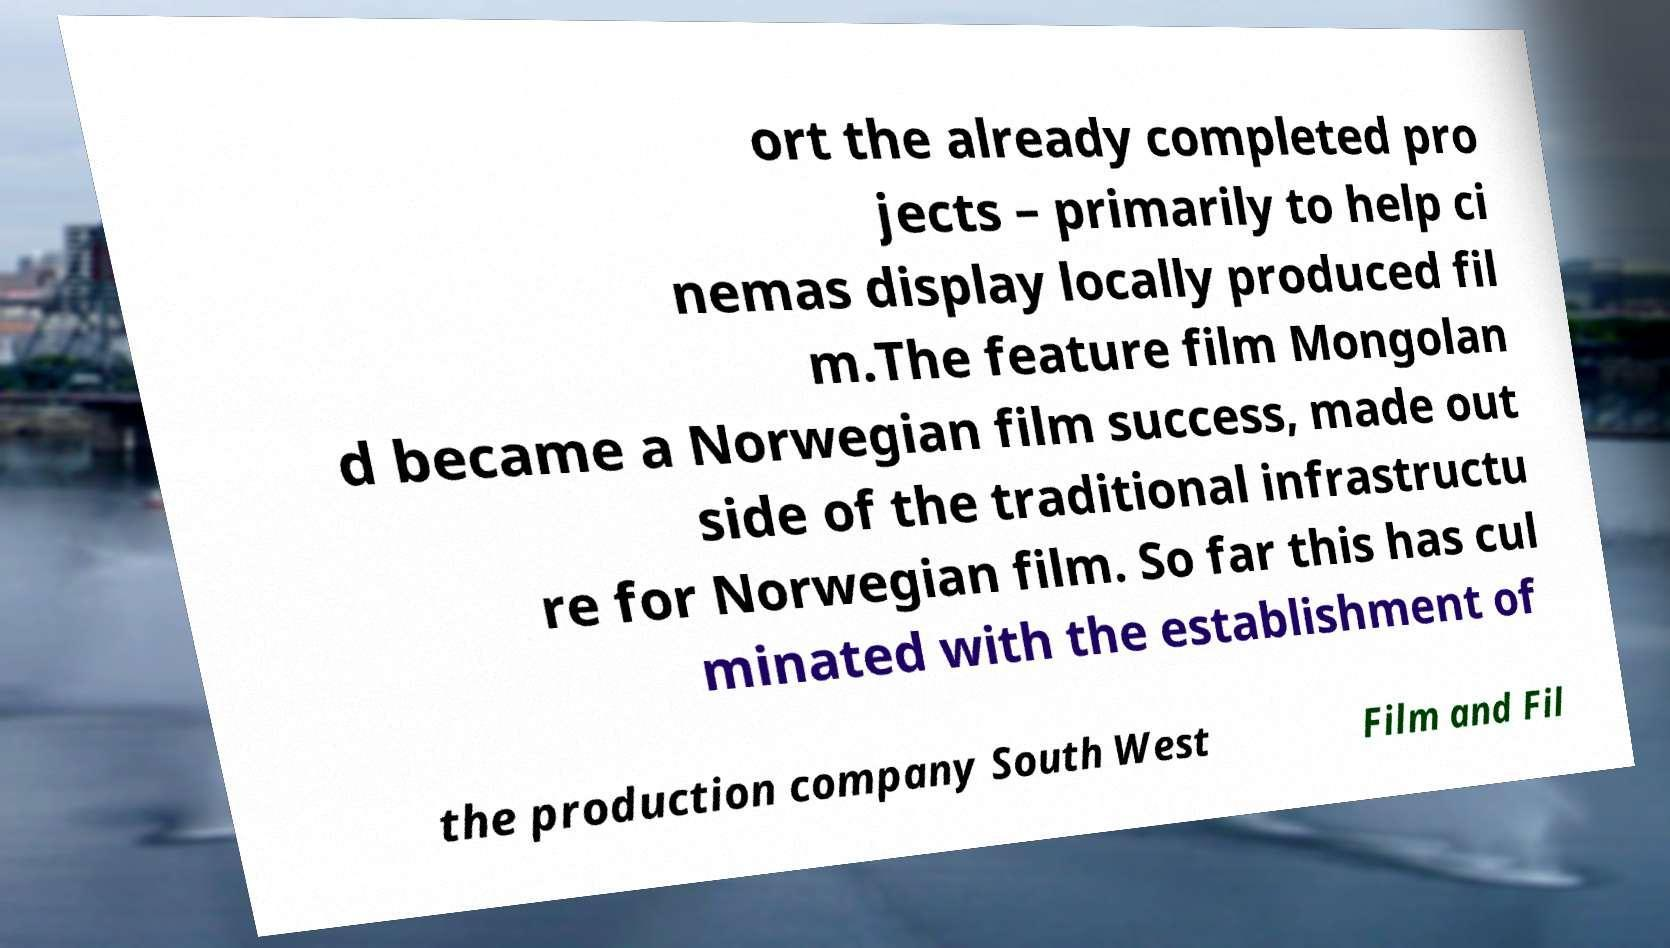Could you extract and type out the text from this image? ort the already completed pro jects – primarily to help ci nemas display locally produced fil m.The feature film Mongolan d became a Norwegian film success, made out side of the traditional infrastructu re for Norwegian film. So far this has cul minated with the establishment of the production company South West Film and Fil 